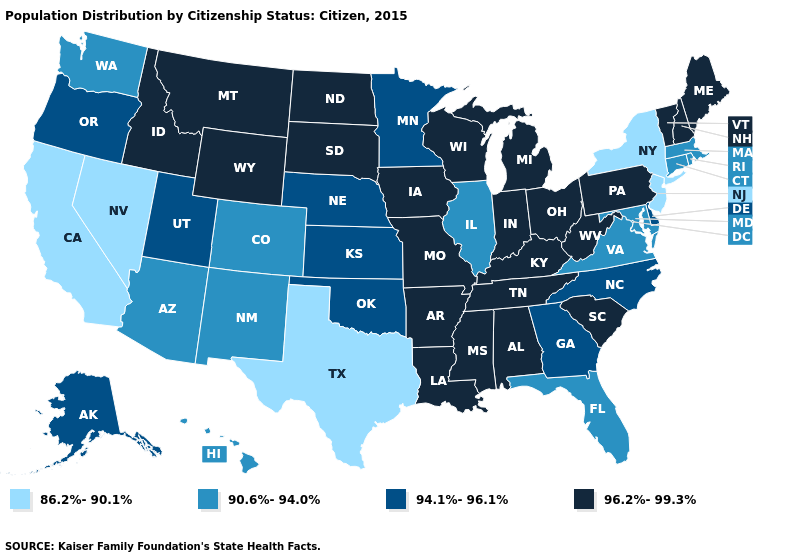Which states have the highest value in the USA?
Keep it brief. Alabama, Arkansas, Idaho, Indiana, Iowa, Kentucky, Louisiana, Maine, Michigan, Mississippi, Missouri, Montana, New Hampshire, North Dakota, Ohio, Pennsylvania, South Carolina, South Dakota, Tennessee, Vermont, West Virginia, Wisconsin, Wyoming. Does Kansas have the highest value in the USA?
Answer briefly. No. What is the value of Kentucky?
Concise answer only. 96.2%-99.3%. What is the value of North Dakota?
Answer briefly. 96.2%-99.3%. What is the value of Iowa?
Give a very brief answer. 96.2%-99.3%. Does Utah have the highest value in the West?
Keep it brief. No. Which states have the lowest value in the West?
Keep it brief. California, Nevada. Name the states that have a value in the range 94.1%-96.1%?
Write a very short answer. Alaska, Delaware, Georgia, Kansas, Minnesota, Nebraska, North Carolina, Oklahoma, Oregon, Utah. Among the states that border Pennsylvania , which have the highest value?
Answer briefly. Ohio, West Virginia. What is the value of Alabama?
Write a very short answer. 96.2%-99.3%. What is the lowest value in states that border Maine?
Short answer required. 96.2%-99.3%. Does Nebraska have the highest value in the MidWest?
Give a very brief answer. No. What is the value of Delaware?
Write a very short answer. 94.1%-96.1%. What is the value of Louisiana?
Short answer required. 96.2%-99.3%. What is the lowest value in the USA?
Keep it brief. 86.2%-90.1%. 